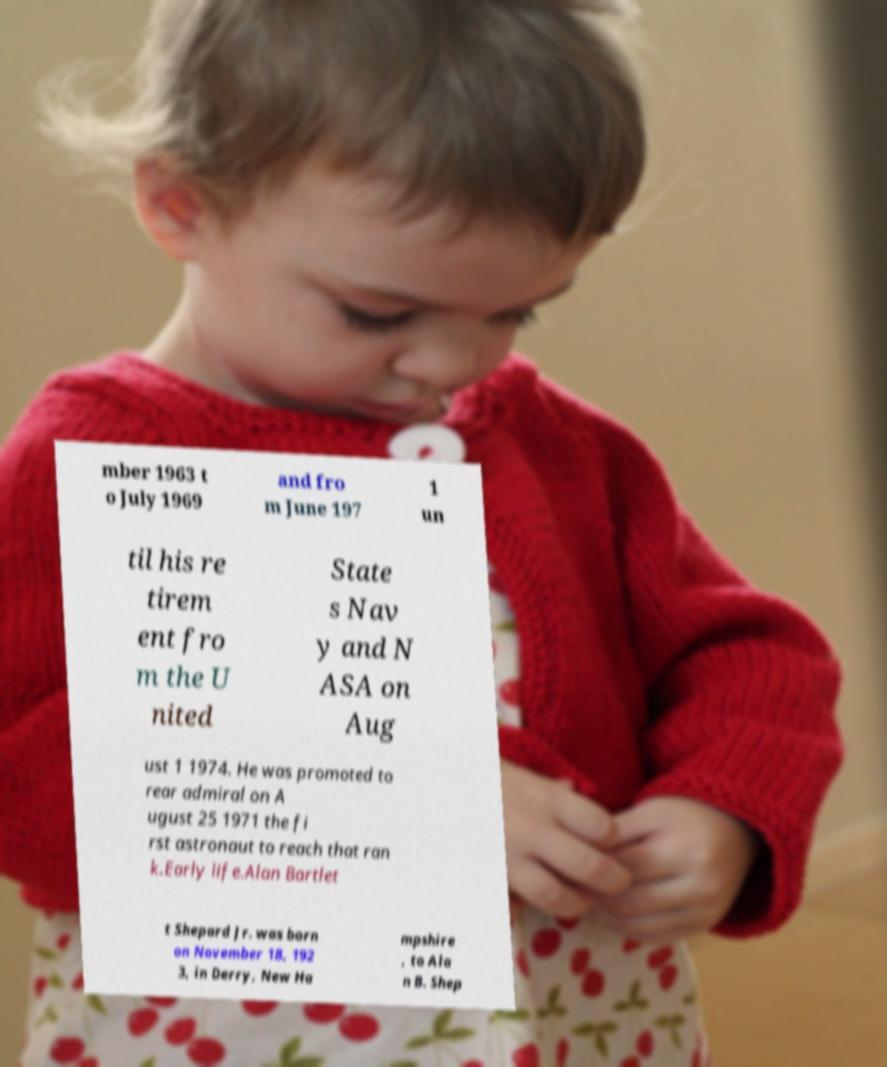I need the written content from this picture converted into text. Can you do that? mber 1963 t o July 1969 and fro m June 197 1 un til his re tirem ent fro m the U nited State s Nav y and N ASA on Aug ust 1 1974. He was promoted to rear admiral on A ugust 25 1971 the fi rst astronaut to reach that ran k.Early life.Alan Bartlet t Shepard Jr. was born on November 18, 192 3, in Derry, New Ha mpshire , to Ala n B. Shep 